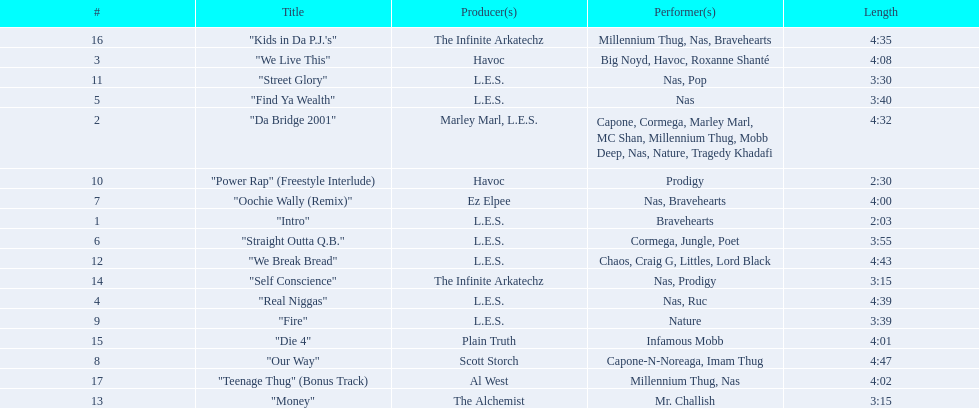How long is each song? 2:03, 4:32, 4:08, 4:39, 3:40, 3:55, 4:00, 4:47, 3:39, 2:30, 3:30, 4:43, 3:15, 3:15, 4:01, 4:35, 4:02. What length is the longest? 4:47. 